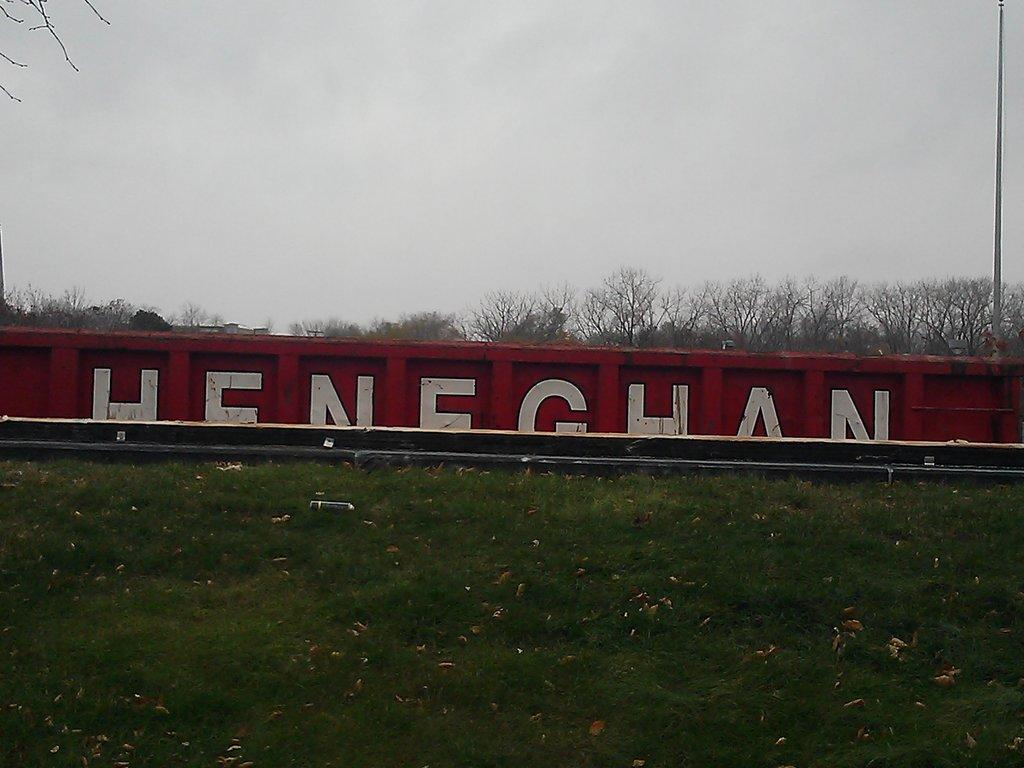<image>
Give a short and clear explanation of the subsequent image. The letters HENEGHAN are able to be about half seen painted on a fence or train car hidden by a grassy hill. 